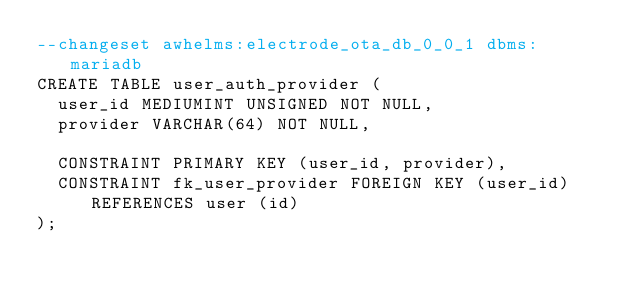Convert code to text. <code><loc_0><loc_0><loc_500><loc_500><_SQL_>--changeset awhelms:electrode_ota_db_0_0_1 dbms:mariadb
CREATE TABLE user_auth_provider (
	user_id MEDIUMINT UNSIGNED NOT NULL,
	provider VARCHAR(64) NOT NULL,
	
	CONSTRAINT PRIMARY KEY (user_id, provider),
	CONSTRAINT fk_user_provider FOREIGN KEY (user_id) REFERENCES user (id)
);
</code> 